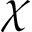Convert formula to latex. <formula><loc_0><loc_0><loc_500><loc_500>\chi</formula> 